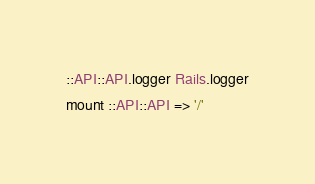<code> <loc_0><loc_0><loc_500><loc_500><_Ruby_>::API::API.logger Rails.logger
mount ::API::API => '/'
</code> 